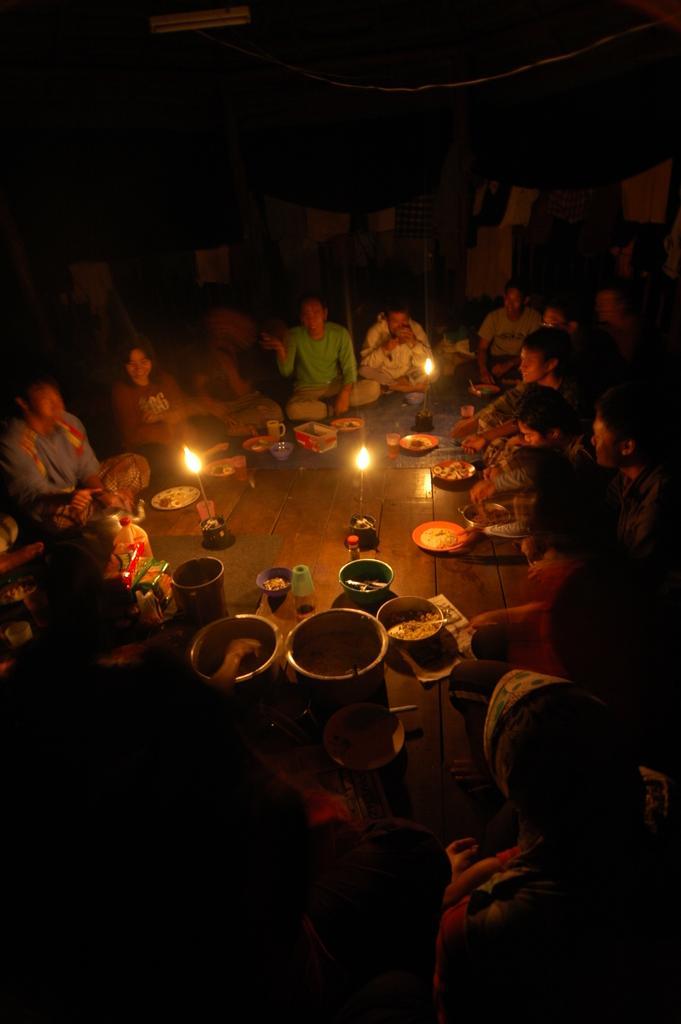How would you summarize this image in a sentence or two? In the image we can see there are people sitting on the floor and there are candles kept on the floor. There are food items kept in the bowls and background of the image is little dark. 